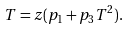Convert formula to latex. <formula><loc_0><loc_0><loc_500><loc_500>T = z ( p _ { 1 } + p _ { 3 } T ^ { 2 } ) .</formula> 